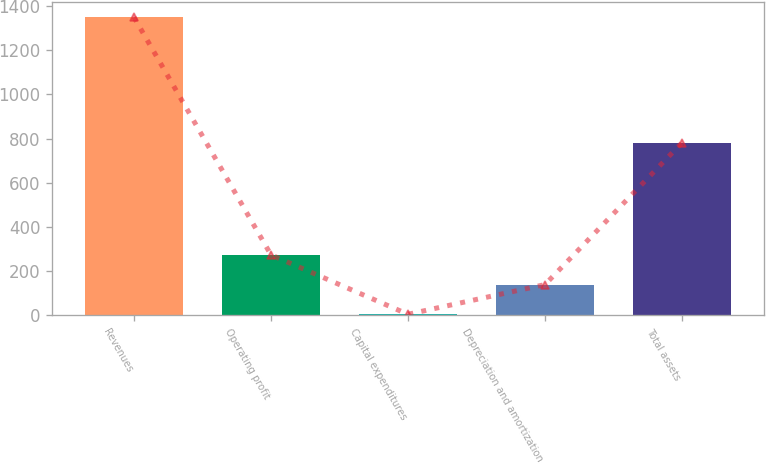Convert chart. <chart><loc_0><loc_0><loc_500><loc_500><bar_chart><fcel>Revenues<fcel>Operating profit<fcel>Capital expenditures<fcel>Depreciation and amortization<fcel>Total assets<nl><fcel>1350<fcel>272.4<fcel>3<fcel>137.7<fcel>781<nl></chart> 